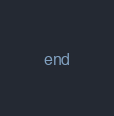<code> <loc_0><loc_0><loc_500><loc_500><_Crystal_>end
</code> 